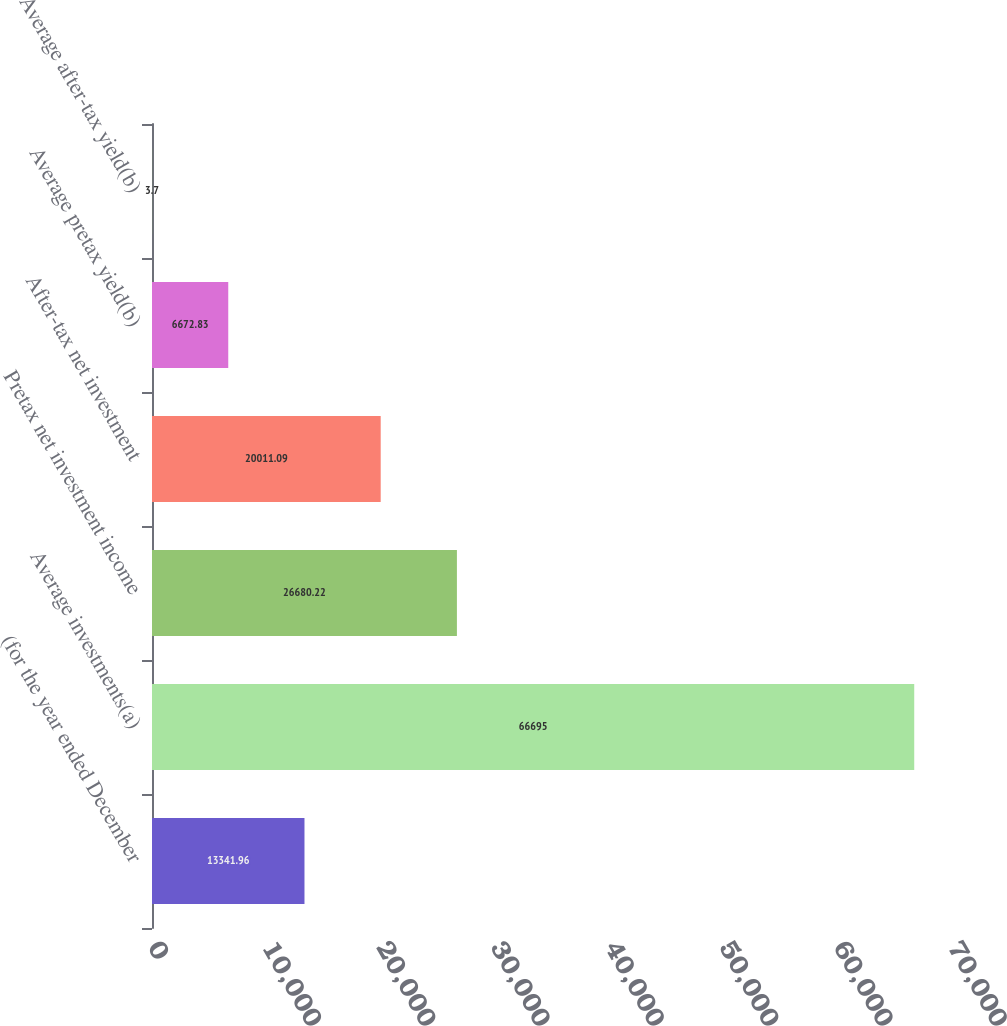Convert chart. <chart><loc_0><loc_0><loc_500><loc_500><bar_chart><fcel>(for the year ended December<fcel>Average investments(a)<fcel>Pretax net investment income<fcel>After-tax net investment<fcel>Average pretax yield(b)<fcel>Average after-tax yield(b)<nl><fcel>13342<fcel>66695<fcel>26680.2<fcel>20011.1<fcel>6672.83<fcel>3.7<nl></chart> 